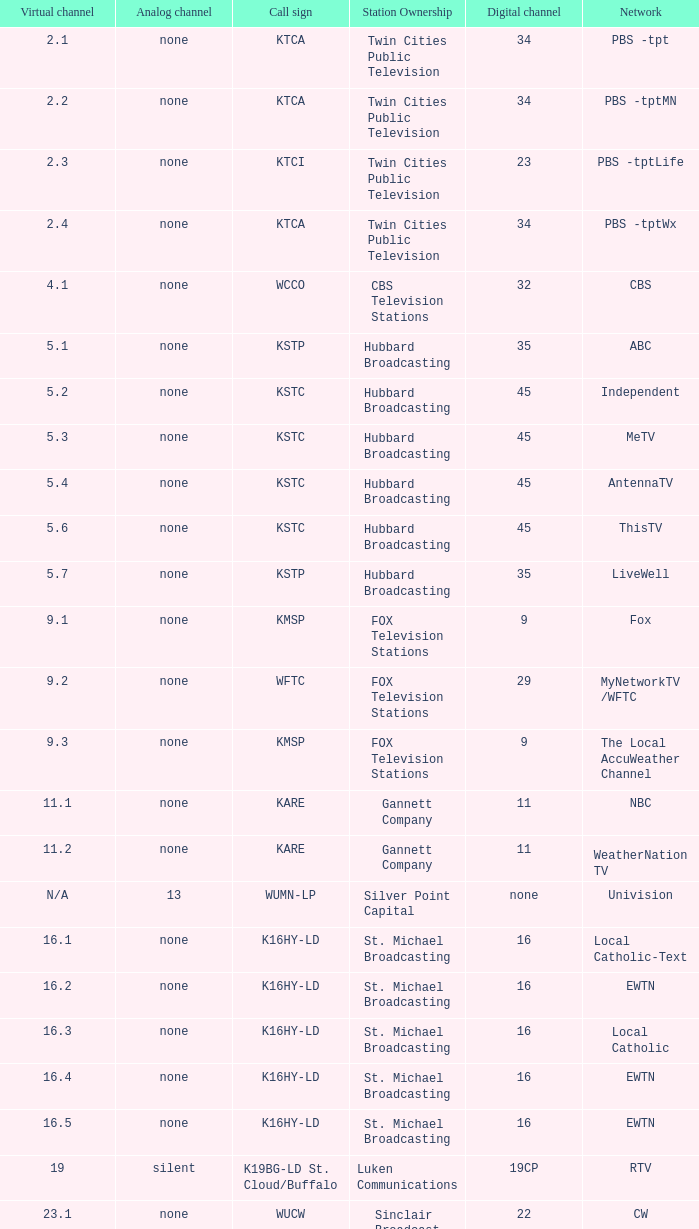Network of nbc is what digital channel? 11.0. 